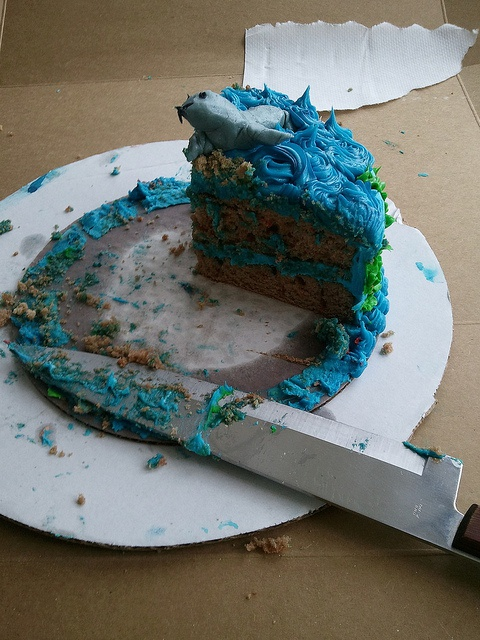Describe the objects in this image and their specific colors. I can see cake in gray, black, teal, blue, and darkblue tones and knife in gray, teal, black, and darkgray tones in this image. 